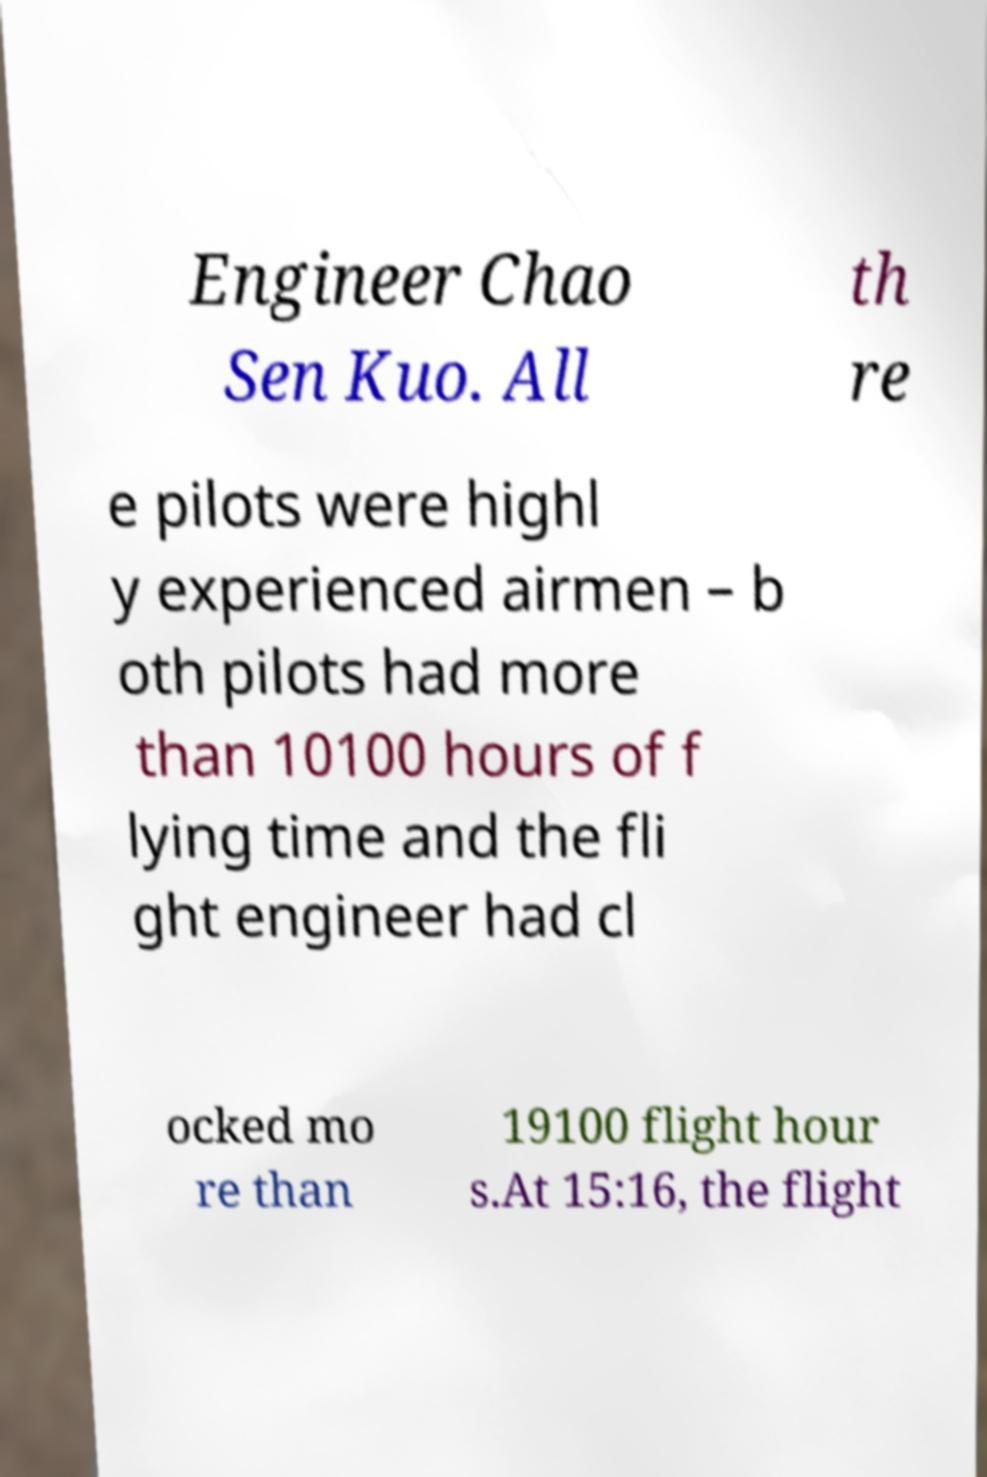Please identify and transcribe the text found in this image. Engineer Chao Sen Kuo. All th re e pilots were highl y experienced airmen – b oth pilots had more than 10100 hours of f lying time and the fli ght engineer had cl ocked mo re than 19100 flight hour s.At 15:16, the flight 